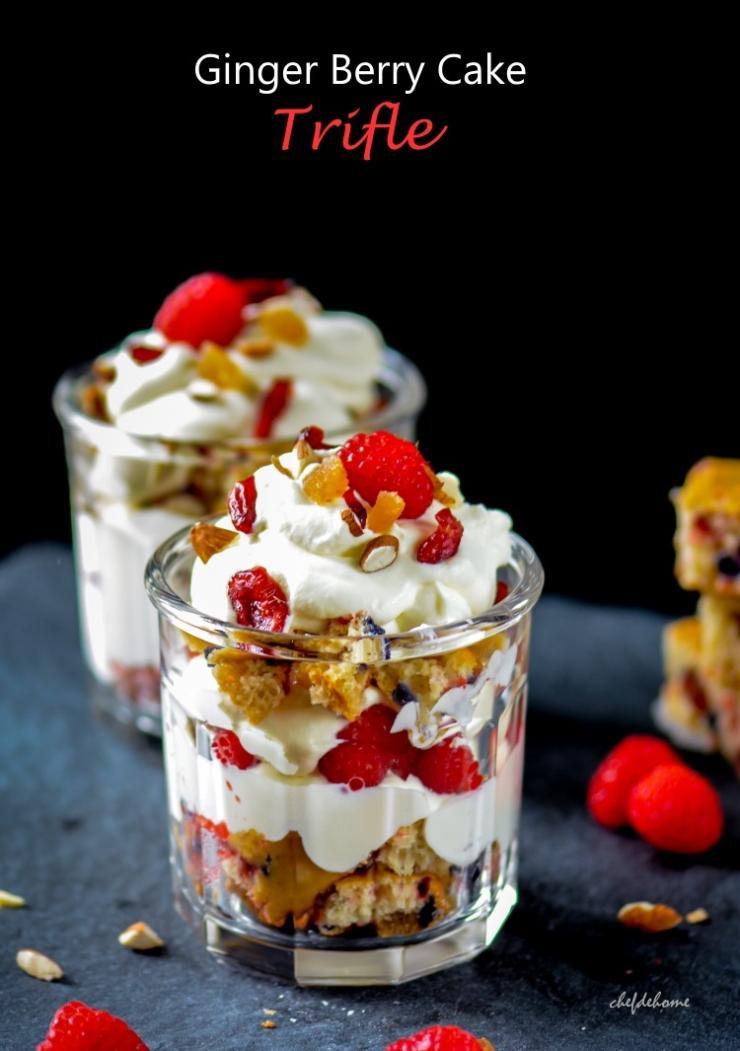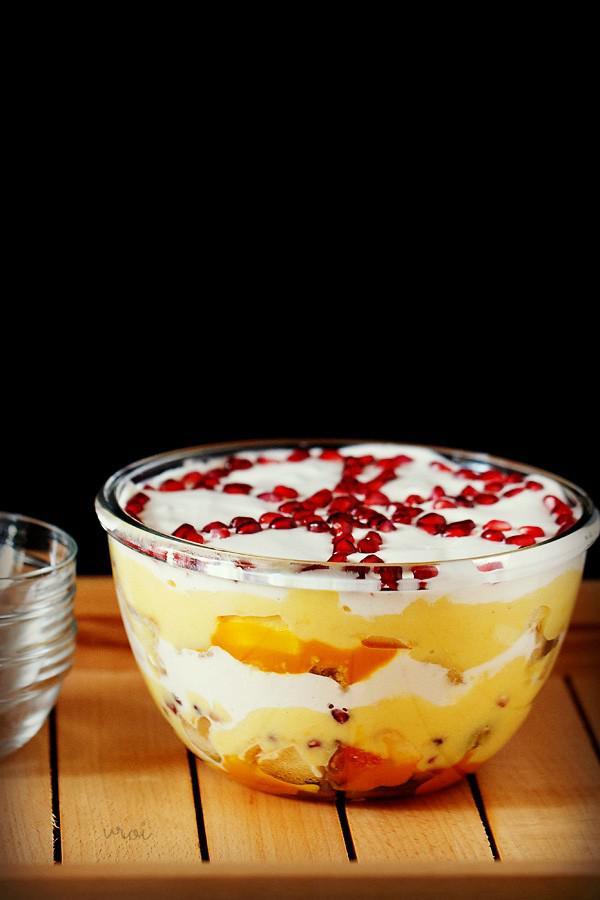The first image is the image on the left, the second image is the image on the right. Assess this claim about the two images: "There are at least 4 parfaits resting on a table.". Correct or not? Answer yes or no. No. 